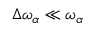Convert formula to latex. <formula><loc_0><loc_0><loc_500><loc_500>\Delta \omega _ { \alpha } \ll \omega _ { \alpha }</formula> 